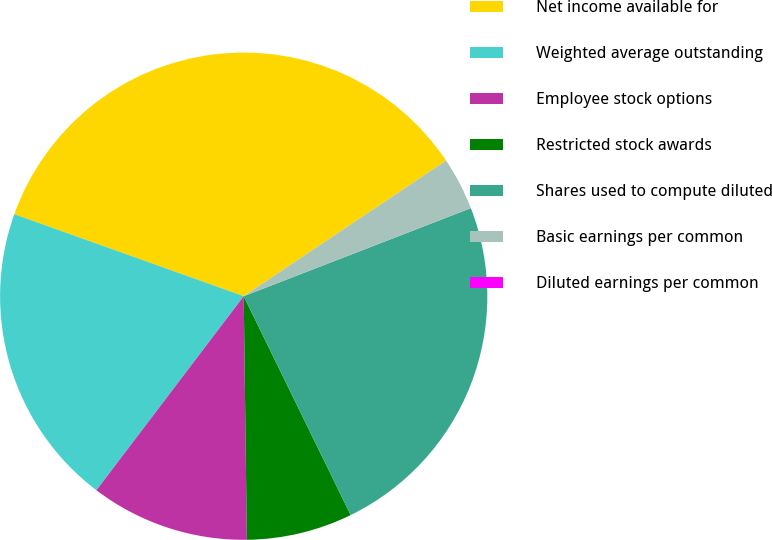<chart> <loc_0><loc_0><loc_500><loc_500><pie_chart><fcel>Net income available for<fcel>Weighted average outstanding<fcel>Employee stock options<fcel>Restricted stock awards<fcel>Shares used to compute diluted<fcel>Basic earnings per common<fcel>Diluted earnings per common<nl><fcel>35.14%<fcel>20.13%<fcel>10.54%<fcel>7.03%<fcel>23.65%<fcel>3.51%<fcel>0.0%<nl></chart> 